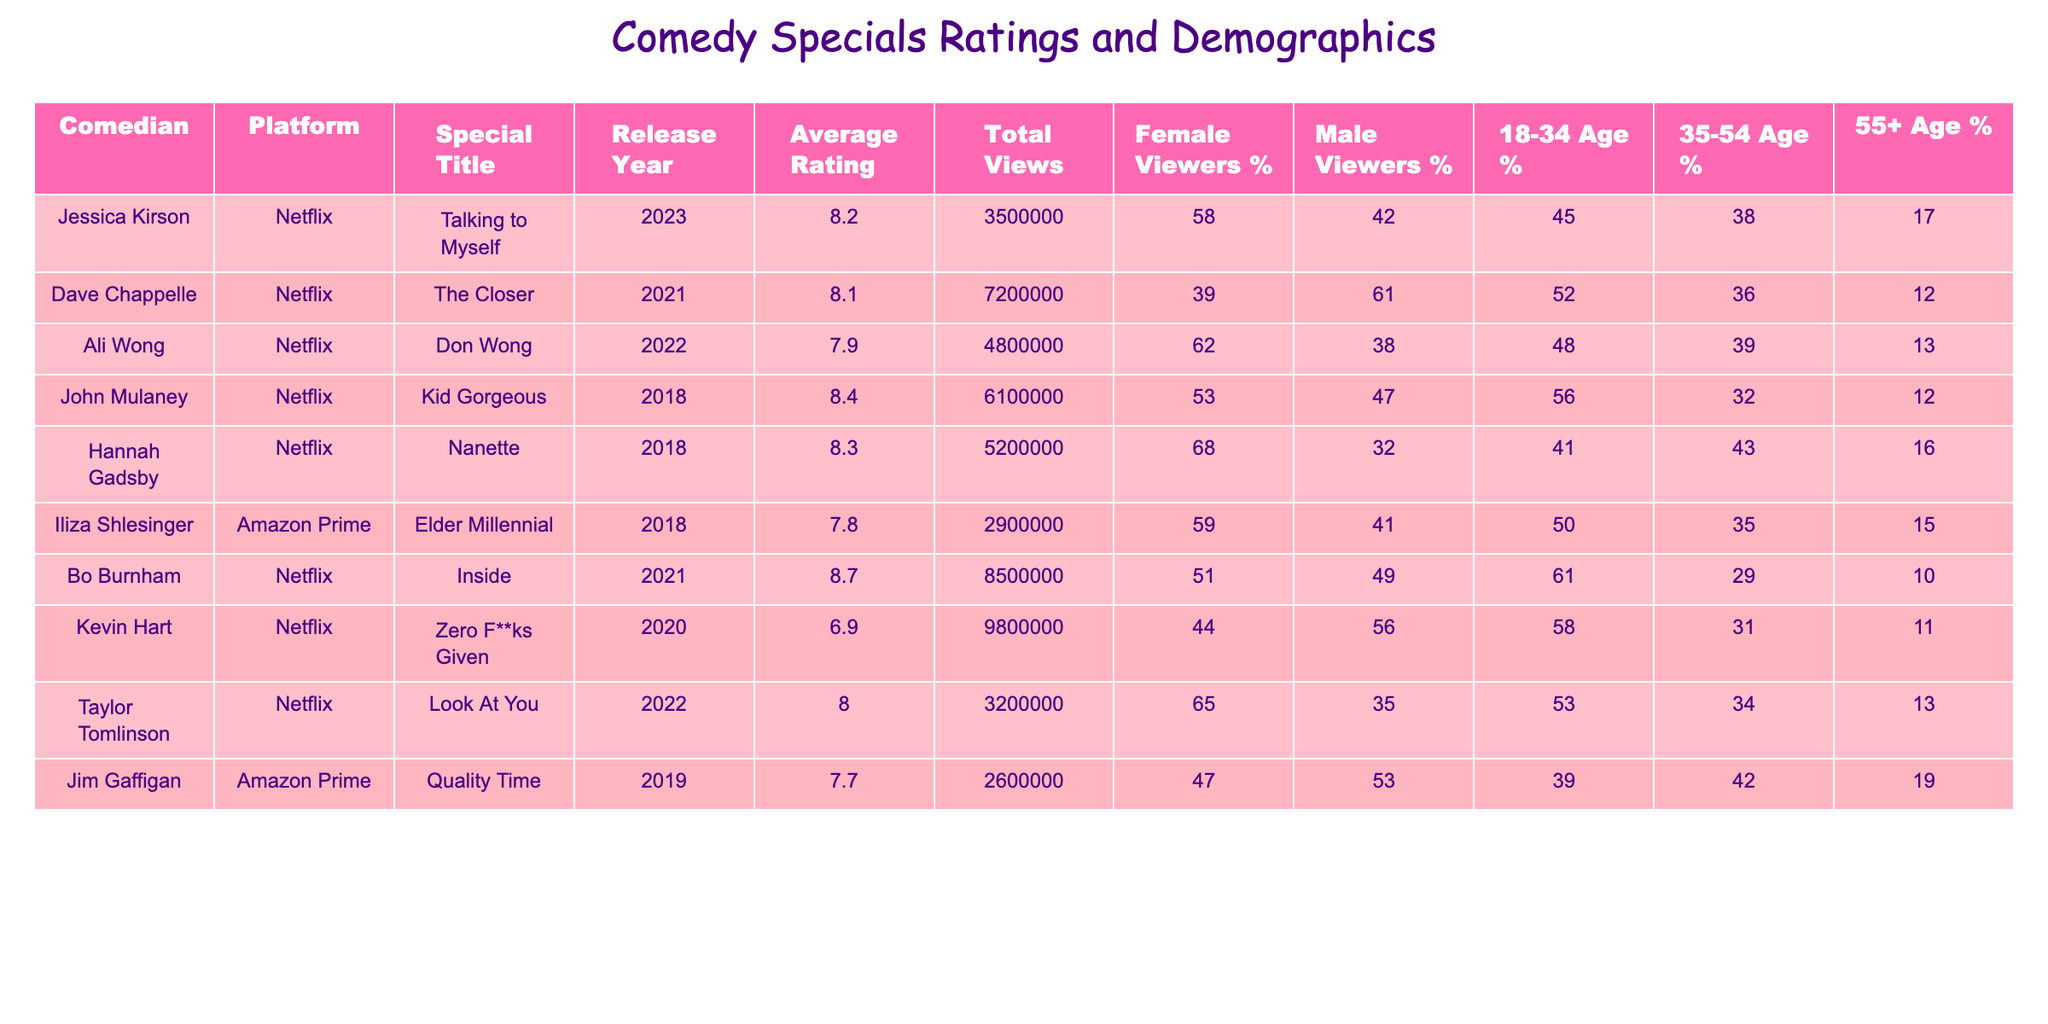What is the average rating of Jessica Kirson's special? The table shows that Jessica Kirson's average rating for her special "Talking to Myself" is 8.2.
Answer: 8.2 Which comedian has the highest average rating? In the table, Bo Burnham has the highest average rating of 8.7 for his special "Inside."
Answer: 8.7 What percentage of female viewers watched "Nanette" by Hannah Gadsby? The table indicates that 68% of the viewers who watched "Nanette" are female.
Answer: 68% What is the total view count for "Zero F**ks Given" by Kevin Hart? The table lists the total view count for "Zero F**ks Given" as 9,800,000.
Answer: 9,800,000 Which special had the lowest average rating and what was it? Kevin Hart's special "Zero F**ks Given" has the lowest average rating of 6.9 according to the table.
Answer: 6.9 How many total views did the special "Don Wong" by Ali Wong receive? According to the table, "Don Wong" received 4,800,000 total views.
Answer: 4,800,000 Is the percentage of male viewers higher for "Kid Gorgeous" than for "Elder Millennial"? The table shows that "Kid Gorgeous" has 47% male viewers, while "Elder Millennial" has 41%, so yes, it is higher.
Answer: Yes What is the difference in average ratings between Hannah Gadsby and Kevin Hart? Hannah Gadsby has an average rating of 8.3 and Kevin Hart has a rating of 6.9. The difference is 8.3 - 6.9 = 1.4.
Answer: 1.4 Among the comedians in the table, who is most popular with viewers aged 35-54? Comparing the percentages, Dave Chappelle has 36% in the 35-54 age group, which is higher than others; therefore, he is most popular in this demographic.
Answer: Dave Chappelle What is the average percentage of female viewers across all specials listed? Adding the female viewer percentages: 58 + 39 + 62 + 53 + 68 + 59 + 44 + 65 + 47 =  495. Dividing by the number of specials (9) gives an average of 55%.
Answer: 55% 